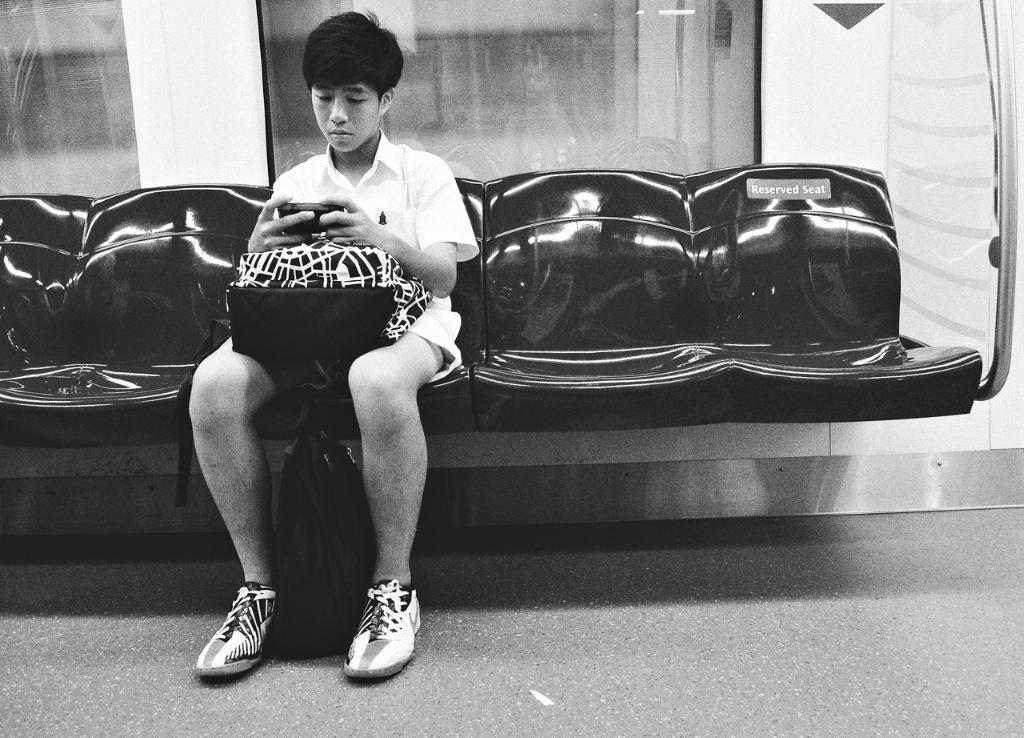What is the man in the image doing? The man is sitting on a seat in the image. What is the man holding in his hand? The man is holding a gadget in the image. What else is the man holding? The man is also holding a bag in the image. What can be seen in the background of the image? There is a rod visible in the image, as well as glass windows. What is the surface the man is sitting on? There is a floor in the image, which the man is sitting on. What type of fight is taking place in the image? There is no fight taking place in the image; it features a man sitting on a seat holding a gadget and a bag. What activity is the rod involved in within the image? The rod is a stationary object in the image and is not involved in any activity. 